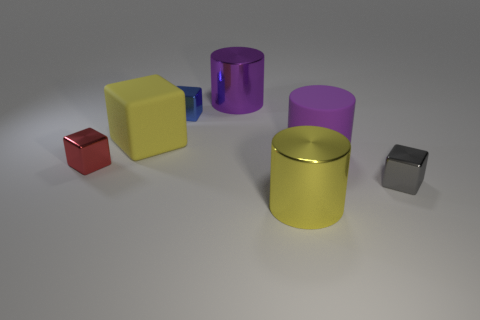Subtract all large purple cylinders. How many cylinders are left? 1 Subtract all brown cubes. How many purple cylinders are left? 2 Subtract 1 cubes. How many cubes are left? 3 Subtract all red blocks. How many blocks are left? 3 Add 1 yellow blocks. How many objects exist? 8 Subtract all red cubes. Subtract all blue cylinders. How many cubes are left? 3 Subtract all cylinders. How many objects are left? 4 Subtract all small matte blocks. Subtract all big yellow shiny things. How many objects are left? 6 Add 4 large purple rubber cylinders. How many large purple rubber cylinders are left? 5 Add 7 cylinders. How many cylinders exist? 10 